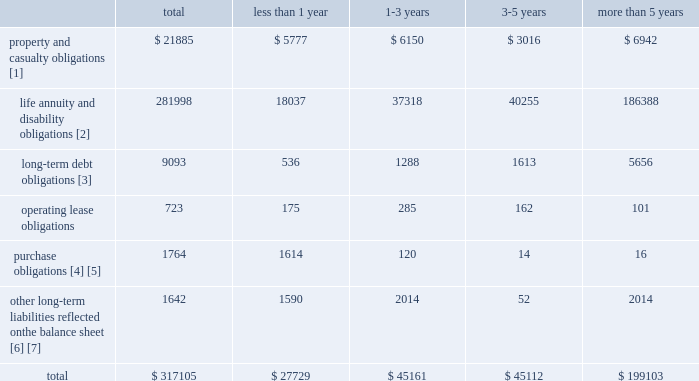The table identifies the company 2019s aggregate contractual obligations due by payment period : payments due by period .
[1] the following points are significant to understanding the cash flows estimated for obligations under property and casualty contracts : reserves for property & casualty unpaid claim and claim adjustment expenses include case reserves for reported claims and reserves for claims incurred but not reported ( ibnr ) .
While payments due on claim reserves are considered contractual obligations because they relate to insurance policies issued by the company , the ultimate amount to be paid to settle both case reserves and ibnr is an estimate , subject to significant uncertainty .
The actual amount to be paid is not determined until the company reaches a settlement with the claimant .
Final claim settlements may vary significantly from the present estimates , particularly since many claims will not be settled until well into the future .
In estimating the timing of future payments by year , the company has assumed that its historical payment patterns will continue .
However , the actual timing of future payments will likely vary materially from these estimates due to , among other things , changes in claim reporting and payment patterns and large unanticipated settlements .
In particular , there is significant uncertainty over the claim payment patterns of asbestos and environmental claims .
Also , estimated payments in 2005 do not include payments that will be made on claims incurred in 2005 on policies that were in force as of december 31 , 2004 .
In addition , the table does not include future cash flows related to the receipt of premiums that will be used , in part , to fund loss payments .
Under generally accepted accounting principles , the company is only permitted to discount reserves for claim and claim adjustment expenses in cases where the payment pattern and ultimate loss costs are fixed and reliably determinable on an individual claim basis .
For the company , these include claim settlements with permanently disabled claimants and certain structured settlement contracts that fund loss runoffs for unrelated parties .
As of december 31 , 2004 , the total property and casualty reserves in the above table of $ 21885 are gross of the reserve discount of $ 556 .
[2] estimated life , annuity and disability obligations include death and disability claims , policy surrenders , policyholder dividends and trail commissions offset by expected future deposits and premiums on in-force contracts .
Estimated contractual policyholder obligations are based on mortality , morbidity and lapse assumptions comparable with life 2019s historical experience , modified for recent observed trends .
Life has also assumed market growth and interest crediting consistent with assumptions used in amortizing deferred acquisition costs .
In contrast to this table , the majority of life 2019s obligations are recorded on the balance sheet at the current account value , as described in critical accounting estimates , and do not incorporate an expectation of future market growth , interest crediting , or future deposits .
Therefore , the estimated contractual policyholder obligations presented in this table significantly exceed the liabilities recorded in reserve for future policy benefits and unpaid claims and claim adjustment expenses , other policyholder funds and benefits payable and separate account liabilities .
Due to the significance of the assumptions used , the amounts presented could materially differ from actual results .
As separate account obligations are legally insulated from general account obligations , the separate account obligations will be fully funded by cash flows from separate account assets .
Life expects to fully fund the general account obligations from cash flows from general account investments and future deposits and premiums .
[3] includes contractual principal and interest payments .
Payments exclude amounts associated with fair-value hedges of certain of the company 2019s long-term debt .
All long-term debt obligations have fixed rates of interest .
Long-term debt obligations also includes principal and interest payments of $ 700 and $ 2.4 billion , respectively , related to junior subordinated debentures which are callable beginning in 2006 .
See note 14 of notes to consolidated financial statements for additional discussion of long-term debt obligations .
[4] includes $ 1.4 billion in commitments to purchase investments including $ 330 of limited partnerships and $ 299 of mortgage loans .
Outstanding commitments under these limited partnerships and mortgage loans are included in payments due in less than 1 year since the timing of funding these commitments cannot be estimated .
The remaining $ 759 relates to payables for securities purchased which are reflected on the company 2019s consolidated balance sheet .
[5] includes estimated contribution of $ 200 to the company 2019s pension plan in 2005 .
[6] as of december 31 , 2004 , the company has accepted cash collateral of $ 1.6 billion in connection with the company 2019s securities lending program and derivative instruments .
Since the timing of the return of the collateral is uncertain , the return of the collateral has been included in the payments due in less than 1 year .
[7] includes $ 52 in collateralized loan obligations ( 201cclos 201d ) issued to third-party investors by a consolidated investment management entity sponsored by the company in connection with synthetic clo transactions .
The clo investors have no recourse to the company 2019s assets other than the dedicated assets collateralizing the clos .
Refer to note 4 of notes to consolidated financial statements for additional discussion of .
What is the percent of the total company 2019s aggregate contractual obligations due for property and casualty obligations in less than 1 year? 
Computations: (5777 / 21885)
Answer: 0.26397. The table identifies the company 2019s aggregate contractual obligations due by payment period : payments due by period .
[1] the following points are significant to understanding the cash flows estimated for obligations under property and casualty contracts : reserves for property & casualty unpaid claim and claim adjustment expenses include case reserves for reported claims and reserves for claims incurred but not reported ( ibnr ) .
While payments due on claim reserves are considered contractual obligations because they relate to insurance policies issued by the company , the ultimate amount to be paid to settle both case reserves and ibnr is an estimate , subject to significant uncertainty .
The actual amount to be paid is not determined until the company reaches a settlement with the claimant .
Final claim settlements may vary significantly from the present estimates , particularly since many claims will not be settled until well into the future .
In estimating the timing of future payments by year , the company has assumed that its historical payment patterns will continue .
However , the actual timing of future payments will likely vary materially from these estimates due to , among other things , changes in claim reporting and payment patterns and large unanticipated settlements .
In particular , there is significant uncertainty over the claim payment patterns of asbestos and environmental claims .
Also , estimated payments in 2005 do not include payments that will be made on claims incurred in 2005 on policies that were in force as of december 31 , 2004 .
In addition , the table does not include future cash flows related to the receipt of premiums that will be used , in part , to fund loss payments .
Under generally accepted accounting principles , the company is only permitted to discount reserves for claim and claim adjustment expenses in cases where the payment pattern and ultimate loss costs are fixed and reliably determinable on an individual claim basis .
For the company , these include claim settlements with permanently disabled claimants and certain structured settlement contracts that fund loss runoffs for unrelated parties .
As of december 31 , 2004 , the total property and casualty reserves in the above table of $ 21885 are gross of the reserve discount of $ 556 .
[2] estimated life , annuity and disability obligations include death and disability claims , policy surrenders , policyholder dividends and trail commissions offset by expected future deposits and premiums on in-force contracts .
Estimated contractual policyholder obligations are based on mortality , morbidity and lapse assumptions comparable with life 2019s historical experience , modified for recent observed trends .
Life has also assumed market growth and interest crediting consistent with assumptions used in amortizing deferred acquisition costs .
In contrast to this table , the majority of life 2019s obligations are recorded on the balance sheet at the current account value , as described in critical accounting estimates , and do not incorporate an expectation of future market growth , interest crediting , or future deposits .
Therefore , the estimated contractual policyholder obligations presented in this table significantly exceed the liabilities recorded in reserve for future policy benefits and unpaid claims and claim adjustment expenses , other policyholder funds and benefits payable and separate account liabilities .
Due to the significance of the assumptions used , the amounts presented could materially differ from actual results .
As separate account obligations are legally insulated from general account obligations , the separate account obligations will be fully funded by cash flows from separate account assets .
Life expects to fully fund the general account obligations from cash flows from general account investments and future deposits and premiums .
[3] includes contractual principal and interest payments .
Payments exclude amounts associated with fair-value hedges of certain of the company 2019s long-term debt .
All long-term debt obligations have fixed rates of interest .
Long-term debt obligations also includes principal and interest payments of $ 700 and $ 2.4 billion , respectively , related to junior subordinated debentures which are callable beginning in 2006 .
See note 14 of notes to consolidated financial statements for additional discussion of long-term debt obligations .
[4] includes $ 1.4 billion in commitments to purchase investments including $ 330 of limited partnerships and $ 299 of mortgage loans .
Outstanding commitments under these limited partnerships and mortgage loans are included in payments due in less than 1 year since the timing of funding these commitments cannot be estimated .
The remaining $ 759 relates to payables for securities purchased which are reflected on the company 2019s consolidated balance sheet .
[5] includes estimated contribution of $ 200 to the company 2019s pension plan in 2005 .
[6] as of december 31 , 2004 , the company has accepted cash collateral of $ 1.6 billion in connection with the company 2019s securities lending program and derivative instruments .
Since the timing of the return of the collateral is uncertain , the return of the collateral has been included in the payments due in less than 1 year .
[7] includes $ 52 in collateralized loan obligations ( 201cclos 201d ) issued to third-party investors by a consolidated investment management entity sponsored by the company in connection with synthetic clo transactions .
The clo investors have no recourse to the company 2019s assets other than the dedicated assets collateralizing the clos .
Refer to note 4 of notes to consolidated financial statements for additional discussion of .
What portion of total obligations are due within less than 1 year? 
Computations: (27729 / 317105)
Answer: 0.08744. The table identifies the company 2019s aggregate contractual obligations due by payment period : payments due by period .
[1] the following points are significant to understanding the cash flows estimated for obligations under property and casualty contracts : reserves for property & casualty unpaid claim and claim adjustment expenses include case reserves for reported claims and reserves for claims incurred but not reported ( ibnr ) .
While payments due on claim reserves are considered contractual obligations because they relate to insurance policies issued by the company , the ultimate amount to be paid to settle both case reserves and ibnr is an estimate , subject to significant uncertainty .
The actual amount to be paid is not determined until the company reaches a settlement with the claimant .
Final claim settlements may vary significantly from the present estimates , particularly since many claims will not be settled until well into the future .
In estimating the timing of future payments by year , the company has assumed that its historical payment patterns will continue .
However , the actual timing of future payments will likely vary materially from these estimates due to , among other things , changes in claim reporting and payment patterns and large unanticipated settlements .
In particular , there is significant uncertainty over the claim payment patterns of asbestos and environmental claims .
Also , estimated payments in 2005 do not include payments that will be made on claims incurred in 2005 on policies that were in force as of december 31 , 2004 .
In addition , the table does not include future cash flows related to the receipt of premiums that will be used , in part , to fund loss payments .
Under generally accepted accounting principles , the company is only permitted to discount reserves for claim and claim adjustment expenses in cases where the payment pattern and ultimate loss costs are fixed and reliably determinable on an individual claim basis .
For the company , these include claim settlements with permanently disabled claimants and certain structured settlement contracts that fund loss runoffs for unrelated parties .
As of december 31 , 2004 , the total property and casualty reserves in the above table of $ 21885 are gross of the reserve discount of $ 556 .
[2] estimated life , annuity and disability obligations include death and disability claims , policy surrenders , policyholder dividends and trail commissions offset by expected future deposits and premiums on in-force contracts .
Estimated contractual policyholder obligations are based on mortality , morbidity and lapse assumptions comparable with life 2019s historical experience , modified for recent observed trends .
Life has also assumed market growth and interest crediting consistent with assumptions used in amortizing deferred acquisition costs .
In contrast to this table , the majority of life 2019s obligations are recorded on the balance sheet at the current account value , as described in critical accounting estimates , and do not incorporate an expectation of future market growth , interest crediting , or future deposits .
Therefore , the estimated contractual policyholder obligations presented in this table significantly exceed the liabilities recorded in reserve for future policy benefits and unpaid claims and claim adjustment expenses , other policyholder funds and benefits payable and separate account liabilities .
Due to the significance of the assumptions used , the amounts presented could materially differ from actual results .
As separate account obligations are legally insulated from general account obligations , the separate account obligations will be fully funded by cash flows from separate account assets .
Life expects to fully fund the general account obligations from cash flows from general account investments and future deposits and premiums .
[3] includes contractual principal and interest payments .
Payments exclude amounts associated with fair-value hedges of certain of the company 2019s long-term debt .
All long-term debt obligations have fixed rates of interest .
Long-term debt obligations also includes principal and interest payments of $ 700 and $ 2.4 billion , respectively , related to junior subordinated debentures which are callable beginning in 2006 .
See note 14 of notes to consolidated financial statements for additional discussion of long-term debt obligations .
[4] includes $ 1.4 billion in commitments to purchase investments including $ 330 of limited partnerships and $ 299 of mortgage loans .
Outstanding commitments under these limited partnerships and mortgage loans are included in payments due in less than 1 year since the timing of funding these commitments cannot be estimated .
The remaining $ 759 relates to payables for securities purchased which are reflected on the company 2019s consolidated balance sheet .
[5] includes estimated contribution of $ 200 to the company 2019s pension plan in 2005 .
[6] as of december 31 , 2004 , the company has accepted cash collateral of $ 1.6 billion in connection with the company 2019s securities lending program and derivative instruments .
Since the timing of the return of the collateral is uncertain , the return of the collateral has been included in the payments due in less than 1 year .
[7] includes $ 52 in collateralized loan obligations ( 201cclos 201d ) issued to third-party investors by a consolidated investment management entity sponsored by the company in connection with synthetic clo transactions .
The clo investors have no recourse to the company 2019s assets other than the dedicated assets collateralizing the clos .
Refer to note 4 of notes to consolidated financial statements for additional discussion of .
What portion of total obligations are due within the next 3 years? 
Computations: ((27729 + 45161) / 317105)
Answer: 0.22986. 